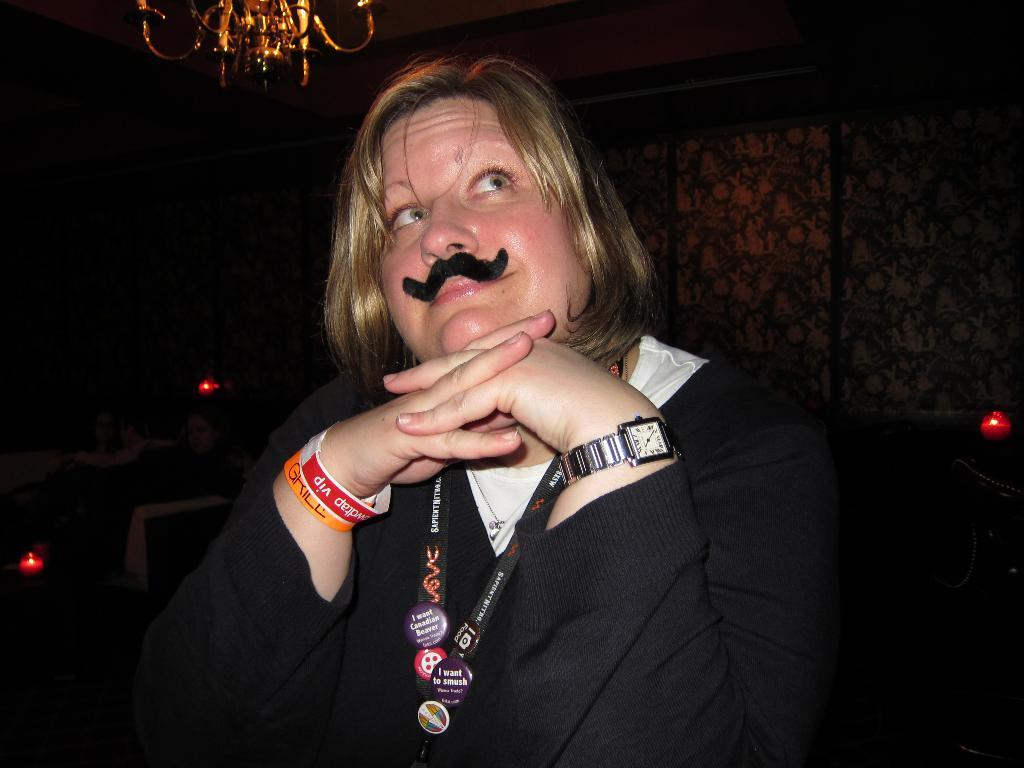What is the person in the image doing? The person is sitting on a chair in the image. What can be seen in the background of the image? There are walls and a chandelier visible in the background of the image. What type of wax is being used to create the goat sculpture in the image? There is no goat sculpture or wax present in the image. 